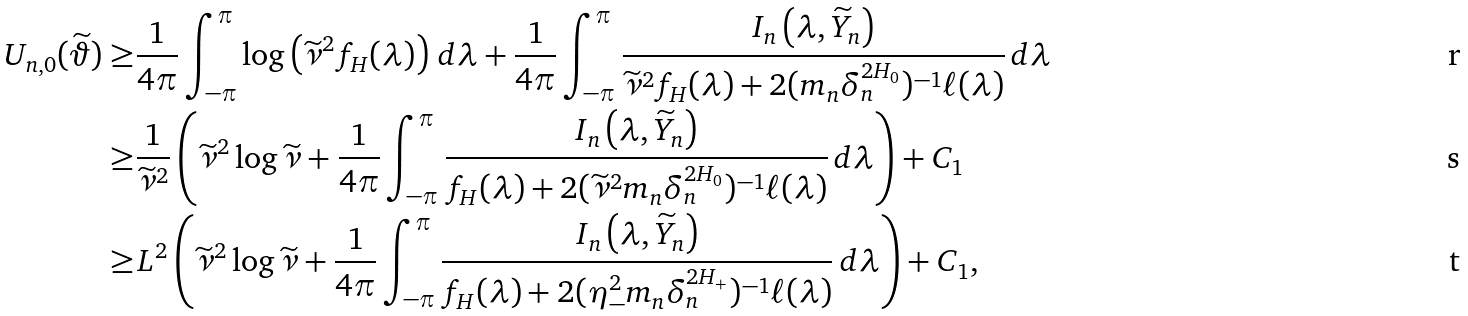<formula> <loc_0><loc_0><loc_500><loc_500>U _ { n , 0 } ( \widetilde { \vartheta } ) \geq & \frac { 1 } { 4 \pi } \int _ { - \pi } ^ { \pi } \log \left ( \widetilde { \nu } ^ { 2 } f _ { H } ( \lambda ) \right ) \, d \lambda + \frac { 1 } { 4 \pi } \int _ { - \pi } ^ { \pi } \frac { I _ { n } \left ( \lambda , \widetilde { Y } _ { n } \right ) } { \widetilde { \nu } ^ { 2 } f _ { H } ( \lambda ) + 2 ( m _ { n } \delta _ { n } ^ { 2 H _ { 0 } } ) ^ { - 1 } \ell ( \lambda ) } \, d \lambda \\ \geq & \frac { 1 } { \widetilde { \nu } ^ { 2 } } \left ( \widetilde { \nu } ^ { 2 } \log \widetilde { \nu } + \frac { 1 } { 4 \pi } \int _ { - \pi } ^ { \pi } \frac { I _ { n } \left ( \lambda , \widetilde { Y } _ { n } \right ) } { f _ { H } ( \lambda ) + 2 ( \widetilde { \nu } ^ { 2 } m _ { n } \delta _ { n } ^ { 2 H _ { 0 } } ) ^ { - 1 } \ell ( \lambda ) } \, d \lambda \right ) + C _ { 1 } \\ \geq & L ^ { 2 } \left ( \widetilde { \nu } ^ { 2 } \log \widetilde { \nu } + \frac { 1 } { 4 \pi } \int _ { - \pi } ^ { \pi } \frac { I _ { n } \left ( \lambda , \widetilde { Y } _ { n } \right ) } { f _ { H } ( \lambda ) + 2 ( \eta _ { - } ^ { 2 } m _ { n } \delta _ { n } ^ { 2 H _ { + } } ) ^ { - 1 } \ell ( \lambda ) } \, d \lambda \right ) + C _ { 1 } ,</formula> 